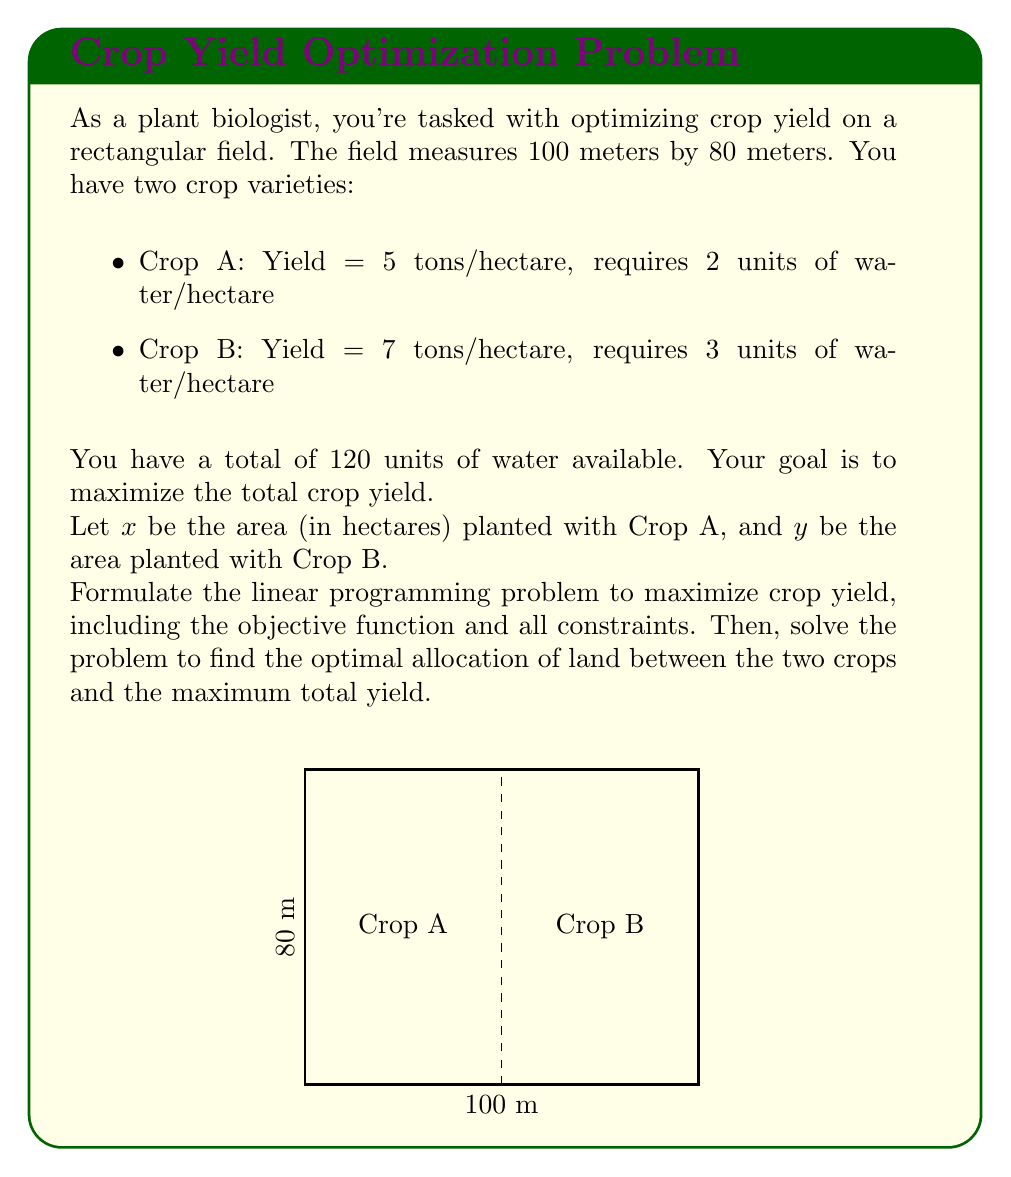Could you help me with this problem? Let's approach this step-by-step:

1) First, we need to set up the objective function and constraints:

   Objective function: Maximize $Z = 5x + 7y$ (total yield in tons)

   Constraints:
   a) Area constraint: $x + y \leq 8$ (total area is 8 hectares)
   b) Water constraint: $2x + 3y \leq 120$ (total water available)
   c) Non-negativity: $x \geq 0, y \geq 0$

2) Now we have a standard linear programming problem. We can solve this using the graphical method or the simplex method. Let's use the graphical method.

3) Plot the constraints:
   - $x + y = 8$ (area constraint)
   - $2x + 3y = 120$ (water constraint)

4) The feasible region is the area that satisfies all constraints, including non-negativity.

5) The optimal solution will be at one of the corner points of this feasible region. The corner points are:
   (0,0), (8,0), (0,40), and the intersection of $x + y = 8$ and $2x + 3y = 120$

6) To find the intersection point, solve:
   $x + y = 8$
   $2x + 3y = 120$

   Subtracting the first equation from the second:
   $x + 2y = 112$
   $x = 112 - 2y$

   Substituting into $x + y = 8$:
   $(112 - 2y) + y = 8$
   $112 - y = 8$
   $y = 104/3 = 34.67$

   $x = 8 - 34.67 = 5.33$

7) Evaluate the objective function at each corner point:
   (0,0): $Z = 0$
   (8,0): $Z = 40$
   (0,40): $Z = 280$
   (5.33, 34.67): $Z = 5(5.33) + 7(34.67) = 269.33$

8) The maximum value is at (0,40), meaning we should plant only Crop B.
Answer: Plant 4 hectares of Crop B for a maximum yield of 280 tons. 